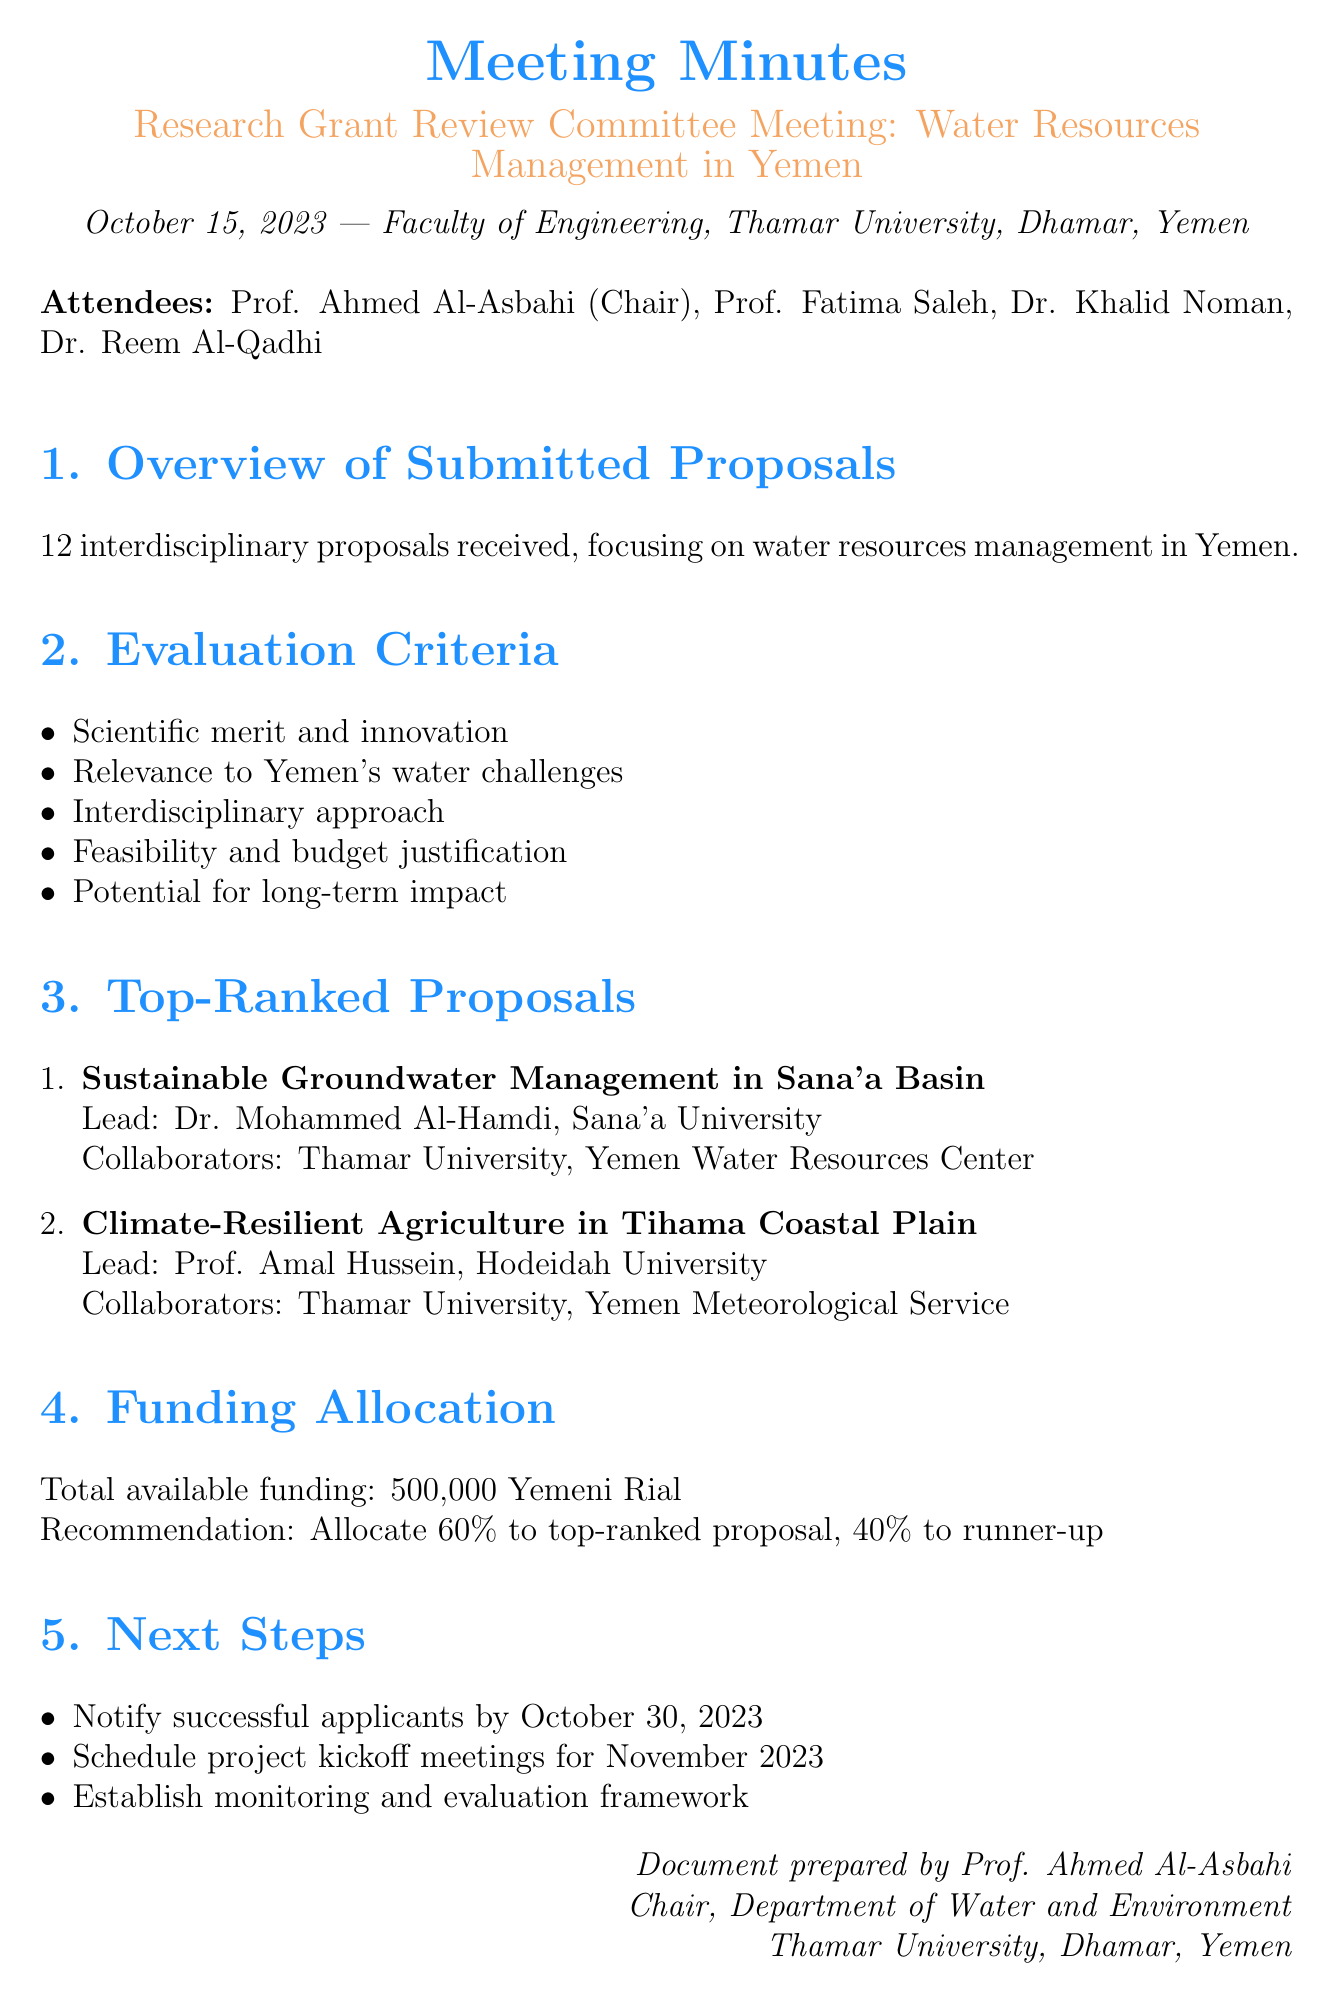What is the meeting title? The meeting title is specified at the beginning of the document, which indicates the focus of the discussion.
Answer: Research Grant Review Committee Meeting: Water Resources Management in Yemen When was the meeting held? The date of the meeting is provided, which is important for understanding the timeline of events.
Answer: October 15, 2023 How many proposals were received? The number of proposals submitted is mentioned in the overview section, crucial for evaluating interest and participation.
Answer: 12 Who is the lead investigator for the top-ranked proposal? The lead investigator for the top-ranked proposal is listed, indicating who is responsible for the project.
Answer: Dr. Mohammed Al-Hamdi What percentage of the total budget is recommended for the top-ranked proposal? The document specifies the recommended allocation percentage, which reflects the decision-making process regarding funding.
Answer: 60% What is the total available funding? The total amount available for funding is stated, which is key for understanding the financial resources at hand.
Answer: 500,000 Yemeni Rial What is one of the evaluation criteria? Some of the evaluation criteria are enumerated, indicating how proposals will be assessed for funding.
Answer: Scientific merit and innovation What actions are proposed for the next steps? The next steps section outlines specific actions planned following the meeting, reflecting plans for implementation.
Answer: Notify successful applicants by October 30, 2023 